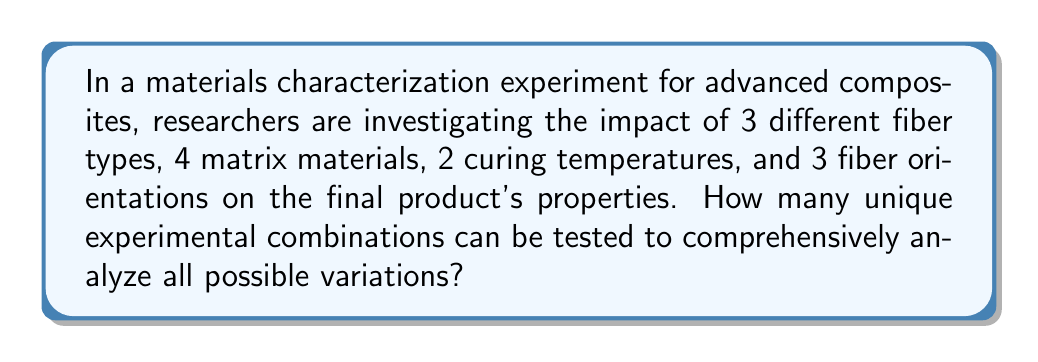Provide a solution to this math problem. To solve this problem, we need to apply the multiplication principle of counting. This principle states that if we have a sequence of choices, and each choice is independent of the others, then the total number of possible outcomes is the product of the number of possibilities for each choice.

Let's break down the given variables:
1. Fiber types: 3 options
2. Matrix materials: 4 options
3. Curing temperatures: 2 options
4. Fiber orientations: 3 options

For each experimental run, the researchers must choose one option from each category. The choices are independent of each other, meaning that selecting one option in a category doesn't affect the choices available in other categories.

Therefore, we can calculate the total number of unique experimental combinations as follows:

$$ \text{Total combinations} = 3 \times 4 \times 2 \times 3 $$

Evaluating this expression:

$$ \text{Total combinations} = 72 $$

This means that to comprehensively analyze all possible variations, the researchers would need to conduct 72 unique experiments, each with a different combination of fiber type, matrix material, curing temperature, and fiber orientation.
Answer: 72 